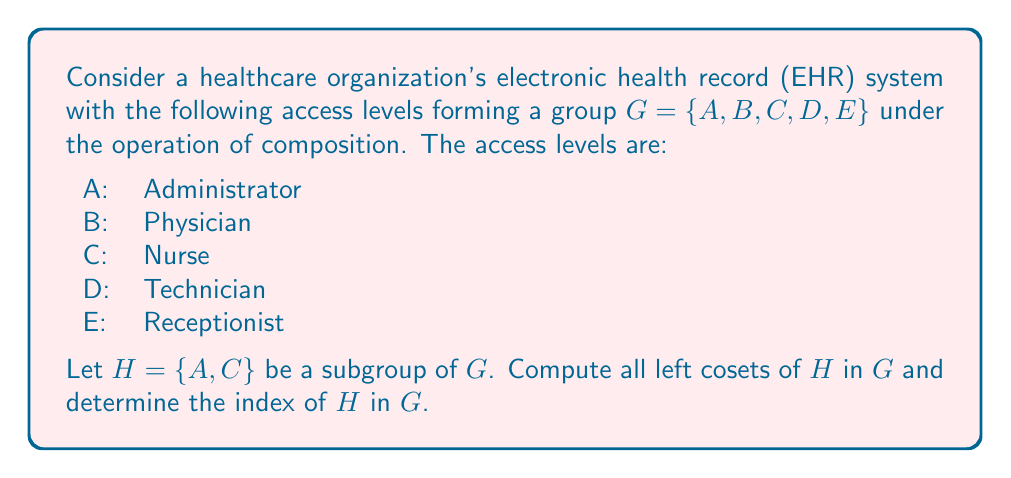Teach me how to tackle this problem. To solve this problem, we'll follow these steps:

1) First, recall that for a subgroup $H$ of a group $G$, the left cosets of $H$ in $G$ are sets of the form $gH = \{gh : h \in H\}$ for each $g \in G$.

2) We need to compute $gH$ for each $g \in G = \{A, B, C, D, E\}$.

3) Let's start with $AH$:
   $AH = \{Ah : h \in H\} = \{AA, AC\} = \{A, C\} = H$

4) Now, let's compute $BH$:
   $BH = \{Bh : h \in H\} = \{BA, BC\} = \{B, B\} = \{B\}$

5) For $CH$:
   $CH = \{Ch : h \in H\} = \{CA, CC\} = \{C, A\} = H$

6) For $DH$:
   $DH = \{Dh : h \in H\} = \{DA, DC\} = \{D, D\} = \{D\}$

7) Finally, for $EH$:
   $EH = \{Eh : h \in H\} = \{EA, EC\} = \{E, E\} = \{E\}$

8) We can see that there are three distinct cosets: $H = \{A, C\}$, $\{B\}$, $\{D\}$, and $\{E\}$.

9) The index of $H$ in $G$, denoted $[G:H]$, is the number of distinct left cosets of $H$ in $G$. From our calculations, we can see that $[G:H] = 4$.

This group theory model demonstrates how different access levels in an EHR system can be organized and analyzed, which is crucial for maintaining proper data security and access control in healthcare technology solutions.
Answer: The left cosets of $H$ in $G$ are:
$H = \{A, C\}$, $\{B\}$, $\{D\}$, and $\{E\}$

The index of $H$ in $G$ is $[G:H] = 4$ 